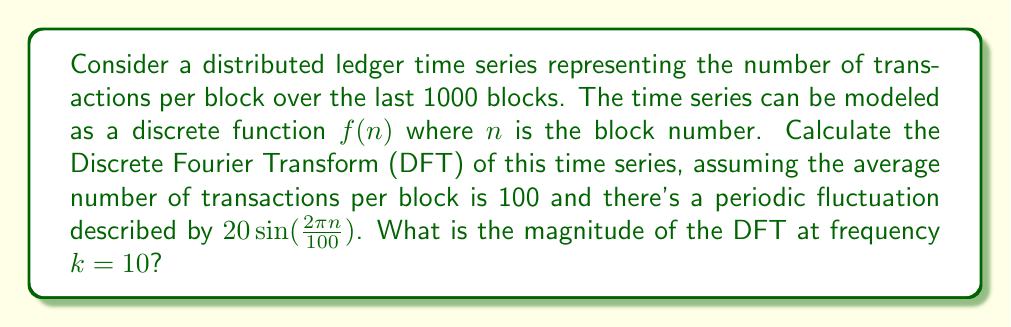Teach me how to tackle this problem. Let's approach this step-by-step:

1) The time series can be described as:
   $$f(n) = 100 + 20\sin(\frac{2\pi n}{100})$$

2) The Discrete Fourier Transform (DFT) is given by:
   $$F(k) = \sum_{n=0}^{N-1} f(n) e^{-i2\pi kn/N}$$
   where $N = 1000$ (the number of blocks)

3) Substituting our function:
   $$F(k) = \sum_{n=0}^{999} (100 + 20\sin(\frac{2\pi n}{100})) e^{-i2\pi kn/1000}$$

4) This can be split into two sums:
   $$F(k) = 100\sum_{n=0}^{999} e^{-i2\pi kn/1000} + 20\sum_{n=0}^{999} \sin(\frac{2\pi n}{100}) e^{-i2\pi kn/1000}$$

5) The first sum is a geometric series that equals 1000 when $k = 0$ and 0 otherwise.

6) The second sum can be simplified using Euler's formula and the linearity of the DFT:
   $$20\sum_{n=0}^{999} \sin(\frac{2\pi n}{100}) e^{-i2\pi kn/1000} = 10i(F(k-10) - F(k+10))$$

7) At $k = 10$, this becomes:
   $$F(10) = 10i(F(0) - F(20))$$

8) $F(0) = 100000$ (from step 5), and $F(20) = 0$

9) Therefore:
   $$F(10) = 10i(100000) = 1000000i$$

10) The magnitude is the absolute value:
    $$|F(10)| = |1000000i| = 1000000$$
Answer: 1000000 